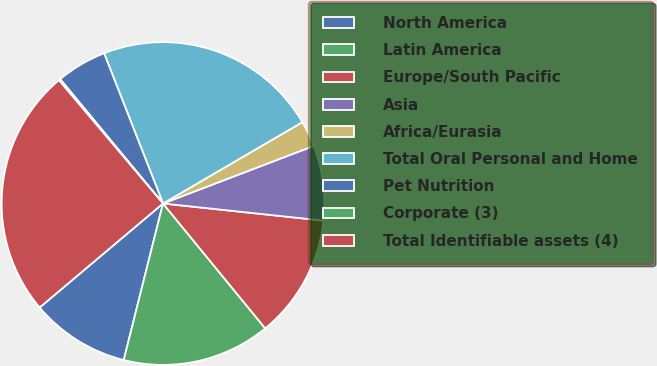<chart> <loc_0><loc_0><loc_500><loc_500><pie_chart><fcel>North America<fcel>Latin America<fcel>Europe/South Pacific<fcel>Asia<fcel>Africa/Eurasia<fcel>Total Oral Personal and Home<fcel>Pet Nutrition<fcel>Corporate (3)<fcel>Total Identifiable assets (4)<nl><fcel>9.94%<fcel>14.83%<fcel>12.39%<fcel>7.5%<fcel>2.6%<fcel>22.54%<fcel>5.05%<fcel>0.16%<fcel>24.99%<nl></chart> 